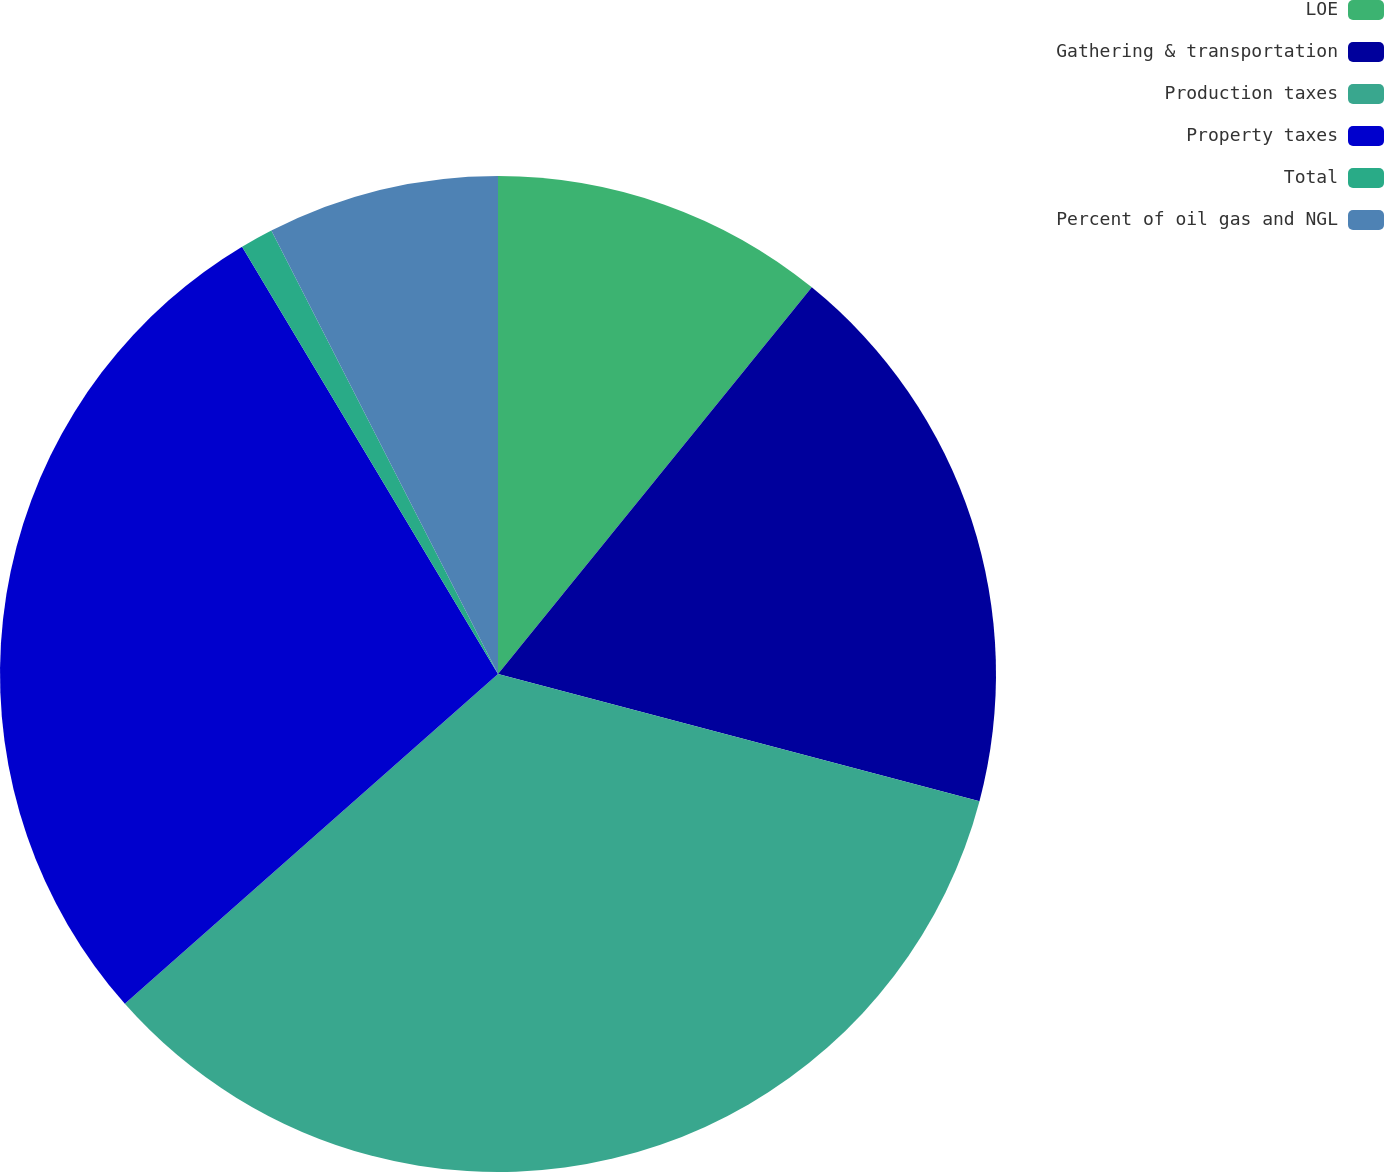Convert chart to OTSL. <chart><loc_0><loc_0><loc_500><loc_500><pie_chart><fcel>LOE<fcel>Gathering & transportation<fcel>Production taxes<fcel>Property taxes<fcel>Total<fcel>Percent of oil gas and NGL<nl><fcel>10.85%<fcel>18.26%<fcel>34.37%<fcel>27.93%<fcel>1.07%<fcel>7.52%<nl></chart> 